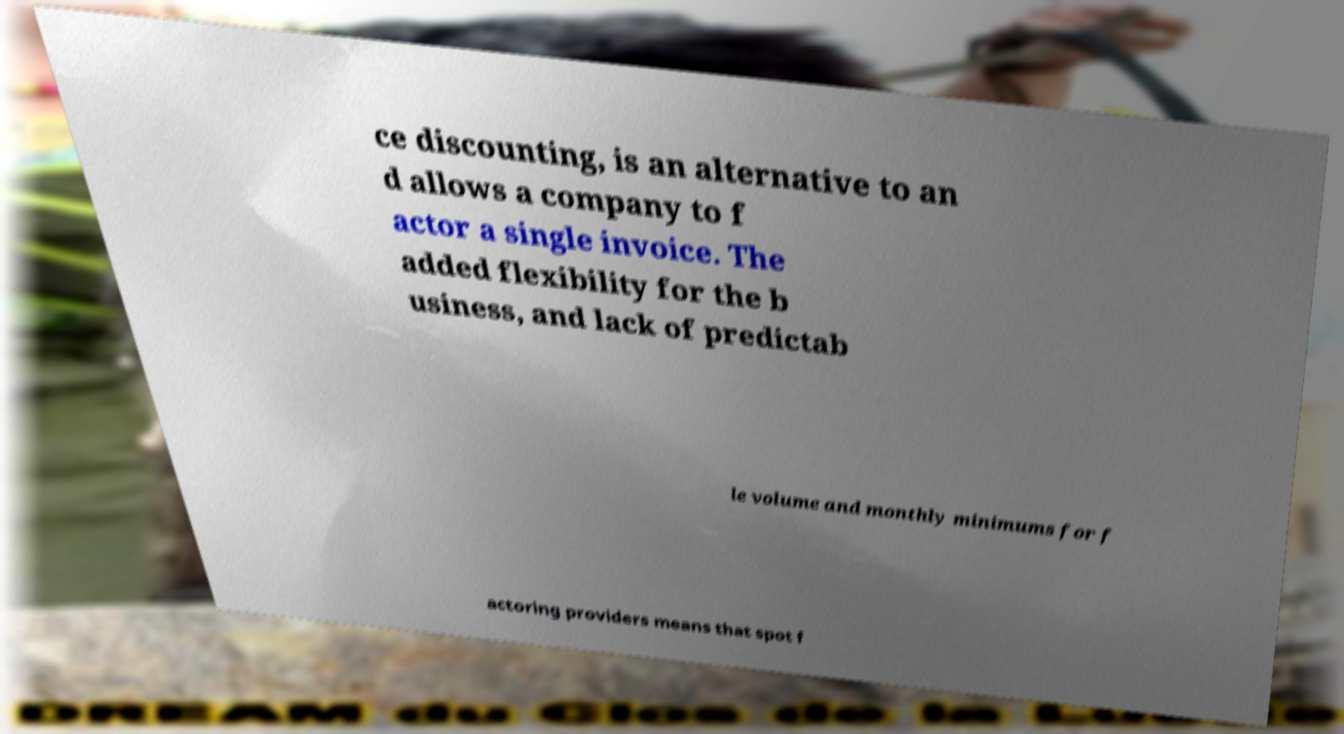What messages or text are displayed in this image? I need them in a readable, typed format. ce discounting, is an alternative to an d allows a company to f actor a single invoice. The added flexibility for the b usiness, and lack of predictab le volume and monthly minimums for f actoring providers means that spot f 